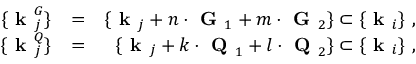<formula> <loc_0><loc_0><loc_500><loc_500>\begin{array} { r l r } { \{ k _ { j } ^ { G } \} } & { = } & { \{ k _ { j } + n \cdot G _ { 1 } + m \cdot G _ { 2 } \} \subset \{ k _ { i } \} , } \\ { \{ k _ { j } ^ { Q } \} } & { = } & { \{ k _ { j } + k \cdot Q _ { 1 } + l \cdot Q _ { 2 } \} \subset \{ k _ { i } \} , } \end{array}</formula> 